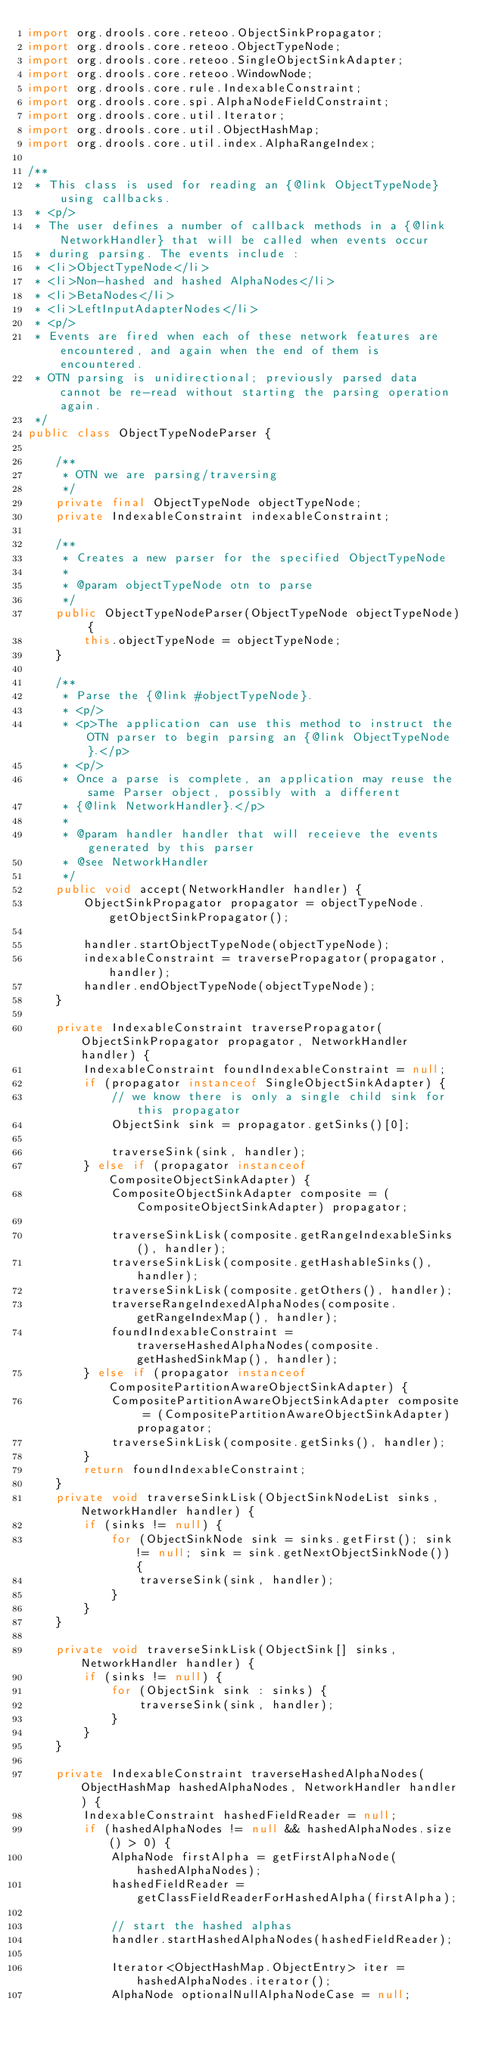<code> <loc_0><loc_0><loc_500><loc_500><_Java_>import org.drools.core.reteoo.ObjectSinkPropagator;
import org.drools.core.reteoo.ObjectTypeNode;
import org.drools.core.reteoo.SingleObjectSinkAdapter;
import org.drools.core.reteoo.WindowNode;
import org.drools.core.rule.IndexableConstraint;
import org.drools.core.spi.AlphaNodeFieldConstraint;
import org.drools.core.util.Iterator;
import org.drools.core.util.ObjectHashMap;
import org.drools.core.util.index.AlphaRangeIndex;

/**
 * This class is used for reading an {@link ObjectTypeNode} using callbacks.
 * <p/>
 * The user defines a number of callback methods in a {@link NetworkHandler} that will be called when events occur
 * during parsing. The events include :
 * <li>ObjectTypeNode</li>
 * <li>Non-hashed and hashed AlphaNodes</li>
 * <li>BetaNodes</li>
 * <li>LeftInputAdapterNodes</li>
 * <p/>
 * Events are fired when each of these network features are encountered, and again when the end of them is encountered.
 * OTN parsing is unidirectional; previously parsed data cannot be re-read without starting the parsing operation again.
 */
public class ObjectTypeNodeParser {

    /**
     * OTN we are parsing/traversing
     */
    private final ObjectTypeNode objectTypeNode;
    private IndexableConstraint indexableConstraint;

    /**
     * Creates a new parser for the specified ObjectTypeNode
     *
     * @param objectTypeNode otn to parse
     */
    public ObjectTypeNodeParser(ObjectTypeNode objectTypeNode) {
        this.objectTypeNode = objectTypeNode;
    }

    /**
     * Parse the {@link #objectTypeNode}.
     * <p/>
     * <p>The application can use this method to instruct the OTN parser to begin parsing an {@link ObjectTypeNode}.</p>
     * <p/>
     * Once a parse is complete, an application may reuse the same Parser object, possibly with a different
     * {@link NetworkHandler}.</p>
     *
     * @param handler handler that will receieve the events generated by this parser
     * @see NetworkHandler
     */
    public void accept(NetworkHandler handler) {
        ObjectSinkPropagator propagator = objectTypeNode.getObjectSinkPropagator();

        handler.startObjectTypeNode(objectTypeNode);
        indexableConstraint = traversePropagator(propagator, handler);
        handler.endObjectTypeNode(objectTypeNode);
    }

    private IndexableConstraint traversePropagator(ObjectSinkPropagator propagator, NetworkHandler handler) {
        IndexableConstraint foundIndexableConstraint = null;
        if (propagator instanceof SingleObjectSinkAdapter) {
            // we know there is only a single child sink for this propagator
            ObjectSink sink = propagator.getSinks()[0];

            traverseSink(sink, handler);
        } else if (propagator instanceof CompositeObjectSinkAdapter) {
            CompositeObjectSinkAdapter composite = (CompositeObjectSinkAdapter) propagator;

            traverseSinkLisk(composite.getRangeIndexableSinks(), handler);
            traverseSinkLisk(composite.getHashableSinks(), handler);
            traverseSinkLisk(composite.getOthers(), handler);
            traverseRangeIndexedAlphaNodes(composite.getRangeIndexMap(), handler);
            foundIndexableConstraint = traverseHashedAlphaNodes(composite.getHashedSinkMap(), handler);
        } else if (propagator instanceof CompositePartitionAwareObjectSinkAdapter) {
            CompositePartitionAwareObjectSinkAdapter composite = (CompositePartitionAwareObjectSinkAdapter) propagator;
            traverseSinkLisk(composite.getSinks(), handler);
        }
        return foundIndexableConstraint;
    }
    private void traverseSinkLisk(ObjectSinkNodeList sinks, NetworkHandler handler) {
        if (sinks != null) {
            for (ObjectSinkNode sink = sinks.getFirst(); sink != null; sink = sink.getNextObjectSinkNode()) {
                traverseSink(sink, handler);
            }
        }
    }

    private void traverseSinkLisk(ObjectSink[] sinks, NetworkHandler handler) {
        if (sinks != null) {
            for (ObjectSink sink : sinks) {
                traverseSink(sink, handler);
            }
        }
    }

    private IndexableConstraint traverseHashedAlphaNodes(ObjectHashMap hashedAlphaNodes, NetworkHandler handler) {
        IndexableConstraint hashedFieldReader = null;
        if (hashedAlphaNodes != null && hashedAlphaNodes.size() > 0) {
            AlphaNode firstAlpha = getFirstAlphaNode(hashedAlphaNodes);
            hashedFieldReader = getClassFieldReaderForHashedAlpha(firstAlpha);

            // start the hashed alphas
            handler.startHashedAlphaNodes(hashedFieldReader);

            Iterator<ObjectHashMap.ObjectEntry> iter = hashedAlphaNodes.iterator();
            AlphaNode optionalNullAlphaNodeCase = null;</code> 